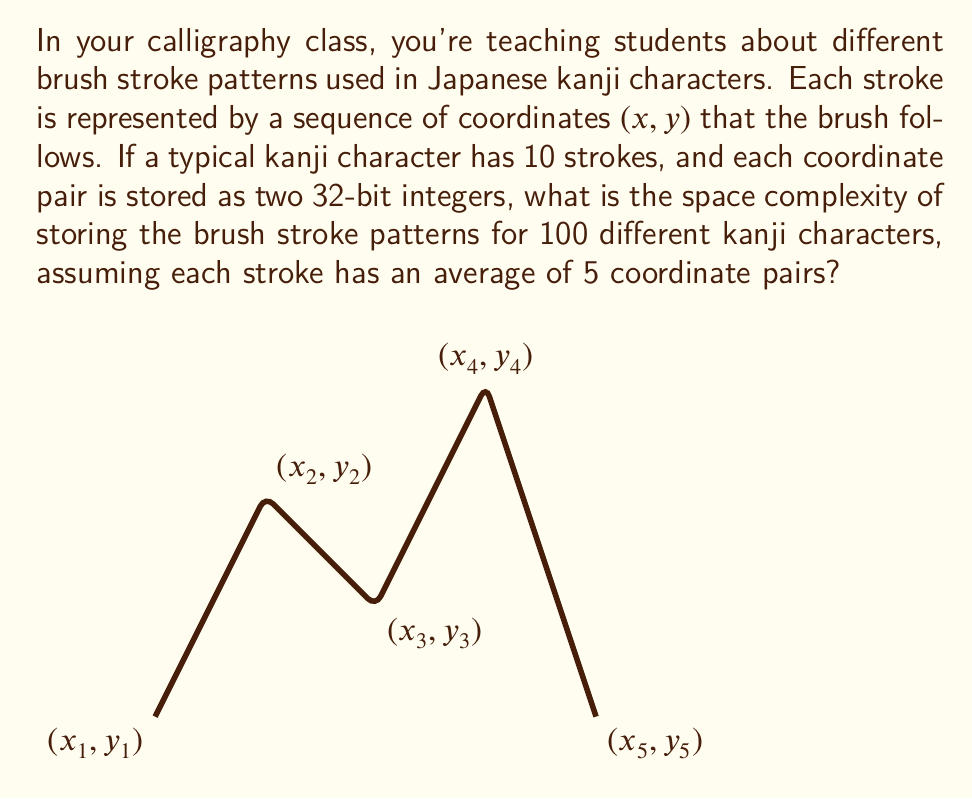Provide a solution to this math problem. Let's break this down step-by-step:

1. First, let's calculate the space needed for one coordinate pair:
   - Each coordinate is a 32-bit integer
   - We need two coordinates (x and y) for each point
   - So, one coordinate pair requires: $2 \times 32 = 64$ bits

2. Now, let's calculate the space for one stroke:
   - Each stroke has an average of 5 coordinate pairs
   - Space for one stroke: $5 \times 64 = 320$ bits

3. Next, let's calculate the space for one kanji character:
   - Each kanji has 10 strokes
   - Space for one kanji: $10 \times 320 = 3,200$ bits

4. Finally, we need to store 100 different kanji characters:
   - Total space: $100 \times 3,200 = 320,000$ bits

5. To express this in a more common unit, let's convert to kilobytes:
   - $320,000 \text{ bits} \div 8 \text{ bits/byte} = 40,000 \text{ bytes}$
   - $40,000 \text{ bytes} \div 1024 \text{ bytes/KB} \approx 39.0625 \text{ KB}$

6. The space complexity in Big O notation is $O(n)$, where n is the number of kanji characters, as the space required grows linearly with the number of characters.
Answer: $O(n)$, approximately 39.0625 KB 